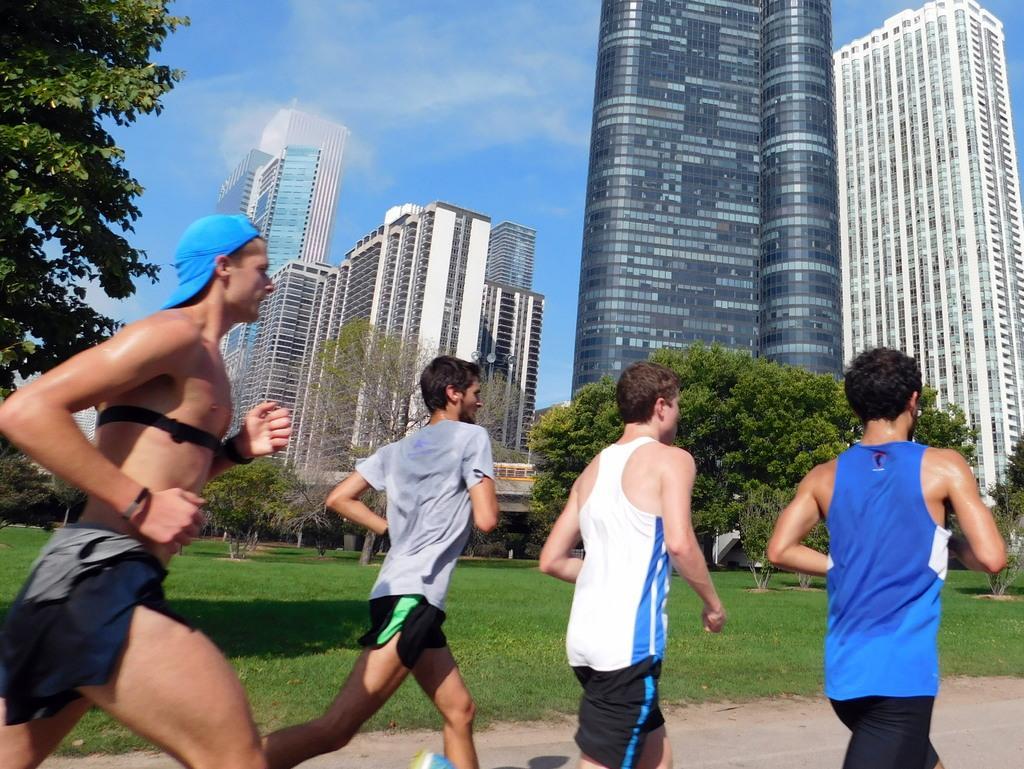Could you give a brief overview of what you see in this image? In the image we can see there are people jogging on the road and there is a ground covered with grass. There are trees and behind there are huge buildings. There is a clear sky. 